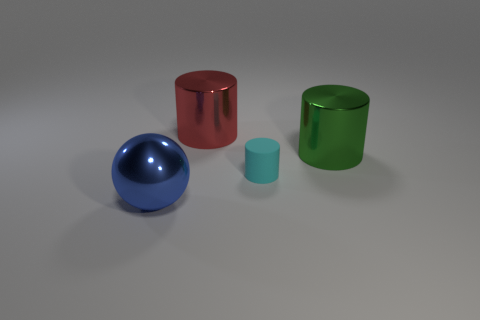Add 3 gray spheres. How many objects exist? 7 Subtract all cylinders. How many objects are left? 1 Subtract all big blue things. Subtract all big spheres. How many objects are left? 2 Add 4 green shiny cylinders. How many green shiny cylinders are left? 5 Add 4 red metallic cylinders. How many red metallic cylinders exist? 5 Subtract 1 green cylinders. How many objects are left? 3 